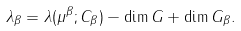Convert formula to latex. <formula><loc_0><loc_0><loc_500><loc_500>\lambda _ { \beta } = \lambda ( \mu ^ { \beta } ; C _ { \beta } ) - \dim G + \dim G _ { \beta } .</formula> 